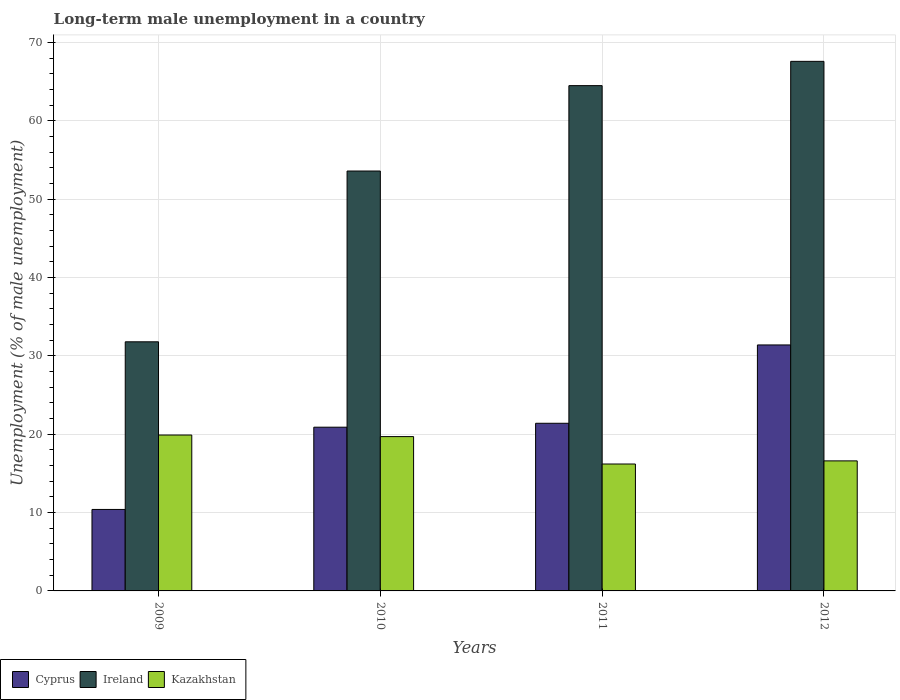How many groups of bars are there?
Ensure brevity in your answer.  4. How many bars are there on the 3rd tick from the right?
Your answer should be compact. 3. What is the label of the 3rd group of bars from the left?
Provide a succinct answer. 2011. What is the percentage of long-term unemployed male population in Cyprus in 2010?
Offer a terse response. 20.9. Across all years, what is the maximum percentage of long-term unemployed male population in Ireland?
Offer a very short reply. 67.6. Across all years, what is the minimum percentage of long-term unemployed male population in Ireland?
Provide a succinct answer. 31.8. In which year was the percentage of long-term unemployed male population in Ireland maximum?
Offer a terse response. 2012. In which year was the percentage of long-term unemployed male population in Cyprus minimum?
Your answer should be very brief. 2009. What is the total percentage of long-term unemployed male population in Ireland in the graph?
Your answer should be compact. 217.5. What is the difference between the percentage of long-term unemployed male population in Kazakhstan in 2011 and that in 2012?
Your response must be concise. -0.4. What is the difference between the percentage of long-term unemployed male population in Cyprus in 2010 and the percentage of long-term unemployed male population in Kazakhstan in 2012?
Your response must be concise. 4.3. What is the average percentage of long-term unemployed male population in Kazakhstan per year?
Make the answer very short. 18.1. In the year 2009, what is the difference between the percentage of long-term unemployed male population in Cyprus and percentage of long-term unemployed male population in Ireland?
Your answer should be very brief. -21.4. In how many years, is the percentage of long-term unemployed male population in Kazakhstan greater than 28 %?
Keep it short and to the point. 0. What is the ratio of the percentage of long-term unemployed male population in Kazakhstan in 2009 to that in 2010?
Provide a short and direct response. 1.01. Is the percentage of long-term unemployed male population in Ireland in 2009 less than that in 2010?
Give a very brief answer. Yes. Is the difference between the percentage of long-term unemployed male population in Cyprus in 2009 and 2012 greater than the difference between the percentage of long-term unemployed male population in Ireland in 2009 and 2012?
Ensure brevity in your answer.  Yes. What is the difference between the highest and the second highest percentage of long-term unemployed male population in Ireland?
Keep it short and to the point. 3.1. What is the difference between the highest and the lowest percentage of long-term unemployed male population in Kazakhstan?
Offer a terse response. 3.7. In how many years, is the percentage of long-term unemployed male population in Ireland greater than the average percentage of long-term unemployed male population in Ireland taken over all years?
Offer a very short reply. 2. What does the 2nd bar from the left in 2010 represents?
Offer a very short reply. Ireland. What does the 1st bar from the right in 2011 represents?
Keep it short and to the point. Kazakhstan. Is it the case that in every year, the sum of the percentage of long-term unemployed male population in Cyprus and percentage of long-term unemployed male population in Ireland is greater than the percentage of long-term unemployed male population in Kazakhstan?
Give a very brief answer. Yes. Are all the bars in the graph horizontal?
Provide a succinct answer. No. How many years are there in the graph?
Keep it short and to the point. 4. Are the values on the major ticks of Y-axis written in scientific E-notation?
Provide a succinct answer. No. How are the legend labels stacked?
Provide a short and direct response. Horizontal. What is the title of the graph?
Offer a terse response. Long-term male unemployment in a country. Does "Angola" appear as one of the legend labels in the graph?
Keep it short and to the point. No. What is the label or title of the Y-axis?
Give a very brief answer. Unemployment (% of male unemployment). What is the Unemployment (% of male unemployment) in Cyprus in 2009?
Ensure brevity in your answer.  10.4. What is the Unemployment (% of male unemployment) in Ireland in 2009?
Offer a very short reply. 31.8. What is the Unemployment (% of male unemployment) in Kazakhstan in 2009?
Offer a terse response. 19.9. What is the Unemployment (% of male unemployment) of Cyprus in 2010?
Provide a short and direct response. 20.9. What is the Unemployment (% of male unemployment) of Ireland in 2010?
Ensure brevity in your answer.  53.6. What is the Unemployment (% of male unemployment) of Kazakhstan in 2010?
Provide a succinct answer. 19.7. What is the Unemployment (% of male unemployment) in Cyprus in 2011?
Your response must be concise. 21.4. What is the Unemployment (% of male unemployment) of Ireland in 2011?
Your answer should be very brief. 64.5. What is the Unemployment (% of male unemployment) in Kazakhstan in 2011?
Keep it short and to the point. 16.2. What is the Unemployment (% of male unemployment) in Cyprus in 2012?
Your answer should be very brief. 31.4. What is the Unemployment (% of male unemployment) in Ireland in 2012?
Your answer should be very brief. 67.6. What is the Unemployment (% of male unemployment) of Kazakhstan in 2012?
Provide a short and direct response. 16.6. Across all years, what is the maximum Unemployment (% of male unemployment) of Cyprus?
Ensure brevity in your answer.  31.4. Across all years, what is the maximum Unemployment (% of male unemployment) in Ireland?
Your answer should be very brief. 67.6. Across all years, what is the maximum Unemployment (% of male unemployment) in Kazakhstan?
Offer a very short reply. 19.9. Across all years, what is the minimum Unemployment (% of male unemployment) of Cyprus?
Give a very brief answer. 10.4. Across all years, what is the minimum Unemployment (% of male unemployment) of Ireland?
Your answer should be very brief. 31.8. Across all years, what is the minimum Unemployment (% of male unemployment) in Kazakhstan?
Your answer should be very brief. 16.2. What is the total Unemployment (% of male unemployment) in Cyprus in the graph?
Provide a short and direct response. 84.1. What is the total Unemployment (% of male unemployment) of Ireland in the graph?
Give a very brief answer. 217.5. What is the total Unemployment (% of male unemployment) in Kazakhstan in the graph?
Offer a terse response. 72.4. What is the difference between the Unemployment (% of male unemployment) of Ireland in 2009 and that in 2010?
Offer a very short reply. -21.8. What is the difference between the Unemployment (% of male unemployment) in Cyprus in 2009 and that in 2011?
Provide a succinct answer. -11. What is the difference between the Unemployment (% of male unemployment) in Ireland in 2009 and that in 2011?
Make the answer very short. -32.7. What is the difference between the Unemployment (% of male unemployment) of Kazakhstan in 2009 and that in 2011?
Your answer should be compact. 3.7. What is the difference between the Unemployment (% of male unemployment) in Cyprus in 2009 and that in 2012?
Keep it short and to the point. -21. What is the difference between the Unemployment (% of male unemployment) of Ireland in 2009 and that in 2012?
Your answer should be very brief. -35.8. What is the difference between the Unemployment (% of male unemployment) of Kazakhstan in 2010 and that in 2011?
Keep it short and to the point. 3.5. What is the difference between the Unemployment (% of male unemployment) of Cyprus in 2010 and that in 2012?
Give a very brief answer. -10.5. What is the difference between the Unemployment (% of male unemployment) of Ireland in 2010 and that in 2012?
Give a very brief answer. -14. What is the difference between the Unemployment (% of male unemployment) of Kazakhstan in 2010 and that in 2012?
Offer a very short reply. 3.1. What is the difference between the Unemployment (% of male unemployment) of Cyprus in 2011 and that in 2012?
Make the answer very short. -10. What is the difference between the Unemployment (% of male unemployment) in Kazakhstan in 2011 and that in 2012?
Offer a very short reply. -0.4. What is the difference between the Unemployment (% of male unemployment) in Cyprus in 2009 and the Unemployment (% of male unemployment) in Ireland in 2010?
Make the answer very short. -43.2. What is the difference between the Unemployment (% of male unemployment) of Cyprus in 2009 and the Unemployment (% of male unemployment) of Kazakhstan in 2010?
Give a very brief answer. -9.3. What is the difference between the Unemployment (% of male unemployment) of Ireland in 2009 and the Unemployment (% of male unemployment) of Kazakhstan in 2010?
Ensure brevity in your answer.  12.1. What is the difference between the Unemployment (% of male unemployment) in Cyprus in 2009 and the Unemployment (% of male unemployment) in Ireland in 2011?
Offer a terse response. -54.1. What is the difference between the Unemployment (% of male unemployment) of Ireland in 2009 and the Unemployment (% of male unemployment) of Kazakhstan in 2011?
Offer a terse response. 15.6. What is the difference between the Unemployment (% of male unemployment) of Cyprus in 2009 and the Unemployment (% of male unemployment) of Ireland in 2012?
Provide a succinct answer. -57.2. What is the difference between the Unemployment (% of male unemployment) in Ireland in 2009 and the Unemployment (% of male unemployment) in Kazakhstan in 2012?
Provide a short and direct response. 15.2. What is the difference between the Unemployment (% of male unemployment) of Cyprus in 2010 and the Unemployment (% of male unemployment) of Ireland in 2011?
Provide a short and direct response. -43.6. What is the difference between the Unemployment (% of male unemployment) in Ireland in 2010 and the Unemployment (% of male unemployment) in Kazakhstan in 2011?
Offer a very short reply. 37.4. What is the difference between the Unemployment (% of male unemployment) in Cyprus in 2010 and the Unemployment (% of male unemployment) in Ireland in 2012?
Your answer should be compact. -46.7. What is the difference between the Unemployment (% of male unemployment) of Ireland in 2010 and the Unemployment (% of male unemployment) of Kazakhstan in 2012?
Provide a short and direct response. 37. What is the difference between the Unemployment (% of male unemployment) of Cyprus in 2011 and the Unemployment (% of male unemployment) of Ireland in 2012?
Offer a very short reply. -46.2. What is the difference between the Unemployment (% of male unemployment) in Cyprus in 2011 and the Unemployment (% of male unemployment) in Kazakhstan in 2012?
Provide a short and direct response. 4.8. What is the difference between the Unemployment (% of male unemployment) of Ireland in 2011 and the Unemployment (% of male unemployment) of Kazakhstan in 2012?
Offer a very short reply. 47.9. What is the average Unemployment (% of male unemployment) in Cyprus per year?
Give a very brief answer. 21.02. What is the average Unemployment (% of male unemployment) in Ireland per year?
Provide a succinct answer. 54.38. What is the average Unemployment (% of male unemployment) in Kazakhstan per year?
Offer a terse response. 18.1. In the year 2009, what is the difference between the Unemployment (% of male unemployment) of Cyprus and Unemployment (% of male unemployment) of Ireland?
Your answer should be very brief. -21.4. In the year 2009, what is the difference between the Unemployment (% of male unemployment) in Cyprus and Unemployment (% of male unemployment) in Kazakhstan?
Offer a very short reply. -9.5. In the year 2010, what is the difference between the Unemployment (% of male unemployment) of Cyprus and Unemployment (% of male unemployment) of Ireland?
Offer a terse response. -32.7. In the year 2010, what is the difference between the Unemployment (% of male unemployment) of Ireland and Unemployment (% of male unemployment) of Kazakhstan?
Provide a short and direct response. 33.9. In the year 2011, what is the difference between the Unemployment (% of male unemployment) in Cyprus and Unemployment (% of male unemployment) in Ireland?
Keep it short and to the point. -43.1. In the year 2011, what is the difference between the Unemployment (% of male unemployment) of Cyprus and Unemployment (% of male unemployment) of Kazakhstan?
Your answer should be very brief. 5.2. In the year 2011, what is the difference between the Unemployment (% of male unemployment) in Ireland and Unemployment (% of male unemployment) in Kazakhstan?
Your answer should be very brief. 48.3. In the year 2012, what is the difference between the Unemployment (% of male unemployment) of Cyprus and Unemployment (% of male unemployment) of Ireland?
Provide a succinct answer. -36.2. In the year 2012, what is the difference between the Unemployment (% of male unemployment) of Cyprus and Unemployment (% of male unemployment) of Kazakhstan?
Offer a very short reply. 14.8. What is the ratio of the Unemployment (% of male unemployment) of Cyprus in 2009 to that in 2010?
Ensure brevity in your answer.  0.5. What is the ratio of the Unemployment (% of male unemployment) of Ireland in 2009 to that in 2010?
Your answer should be very brief. 0.59. What is the ratio of the Unemployment (% of male unemployment) of Kazakhstan in 2009 to that in 2010?
Give a very brief answer. 1.01. What is the ratio of the Unemployment (% of male unemployment) of Cyprus in 2009 to that in 2011?
Offer a very short reply. 0.49. What is the ratio of the Unemployment (% of male unemployment) of Ireland in 2009 to that in 2011?
Give a very brief answer. 0.49. What is the ratio of the Unemployment (% of male unemployment) of Kazakhstan in 2009 to that in 2011?
Make the answer very short. 1.23. What is the ratio of the Unemployment (% of male unemployment) of Cyprus in 2009 to that in 2012?
Your answer should be compact. 0.33. What is the ratio of the Unemployment (% of male unemployment) of Ireland in 2009 to that in 2012?
Provide a short and direct response. 0.47. What is the ratio of the Unemployment (% of male unemployment) in Kazakhstan in 2009 to that in 2012?
Provide a short and direct response. 1.2. What is the ratio of the Unemployment (% of male unemployment) of Cyprus in 2010 to that in 2011?
Ensure brevity in your answer.  0.98. What is the ratio of the Unemployment (% of male unemployment) in Ireland in 2010 to that in 2011?
Offer a very short reply. 0.83. What is the ratio of the Unemployment (% of male unemployment) in Kazakhstan in 2010 to that in 2011?
Provide a succinct answer. 1.22. What is the ratio of the Unemployment (% of male unemployment) of Cyprus in 2010 to that in 2012?
Offer a terse response. 0.67. What is the ratio of the Unemployment (% of male unemployment) in Ireland in 2010 to that in 2012?
Provide a succinct answer. 0.79. What is the ratio of the Unemployment (% of male unemployment) of Kazakhstan in 2010 to that in 2012?
Provide a succinct answer. 1.19. What is the ratio of the Unemployment (% of male unemployment) in Cyprus in 2011 to that in 2012?
Give a very brief answer. 0.68. What is the ratio of the Unemployment (% of male unemployment) of Ireland in 2011 to that in 2012?
Keep it short and to the point. 0.95. What is the ratio of the Unemployment (% of male unemployment) of Kazakhstan in 2011 to that in 2012?
Your answer should be compact. 0.98. What is the difference between the highest and the second highest Unemployment (% of male unemployment) in Ireland?
Offer a terse response. 3.1. What is the difference between the highest and the lowest Unemployment (% of male unemployment) of Cyprus?
Offer a very short reply. 21. What is the difference between the highest and the lowest Unemployment (% of male unemployment) in Ireland?
Offer a terse response. 35.8. What is the difference between the highest and the lowest Unemployment (% of male unemployment) in Kazakhstan?
Make the answer very short. 3.7. 